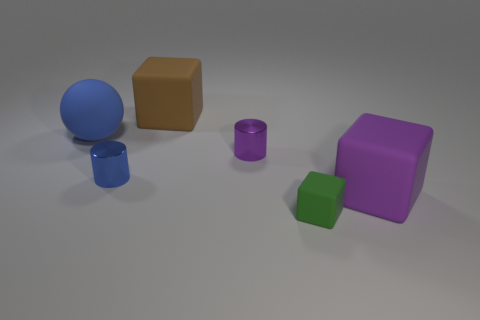Add 3 big blue shiny objects. How many objects exist? 9 Subtract all cylinders. How many objects are left? 4 Subtract 0 yellow balls. How many objects are left? 6 Subtract all metal cylinders. Subtract all tiny brown things. How many objects are left? 4 Add 5 large blue matte balls. How many large blue matte balls are left? 6 Add 1 small green cubes. How many small green cubes exist? 2 